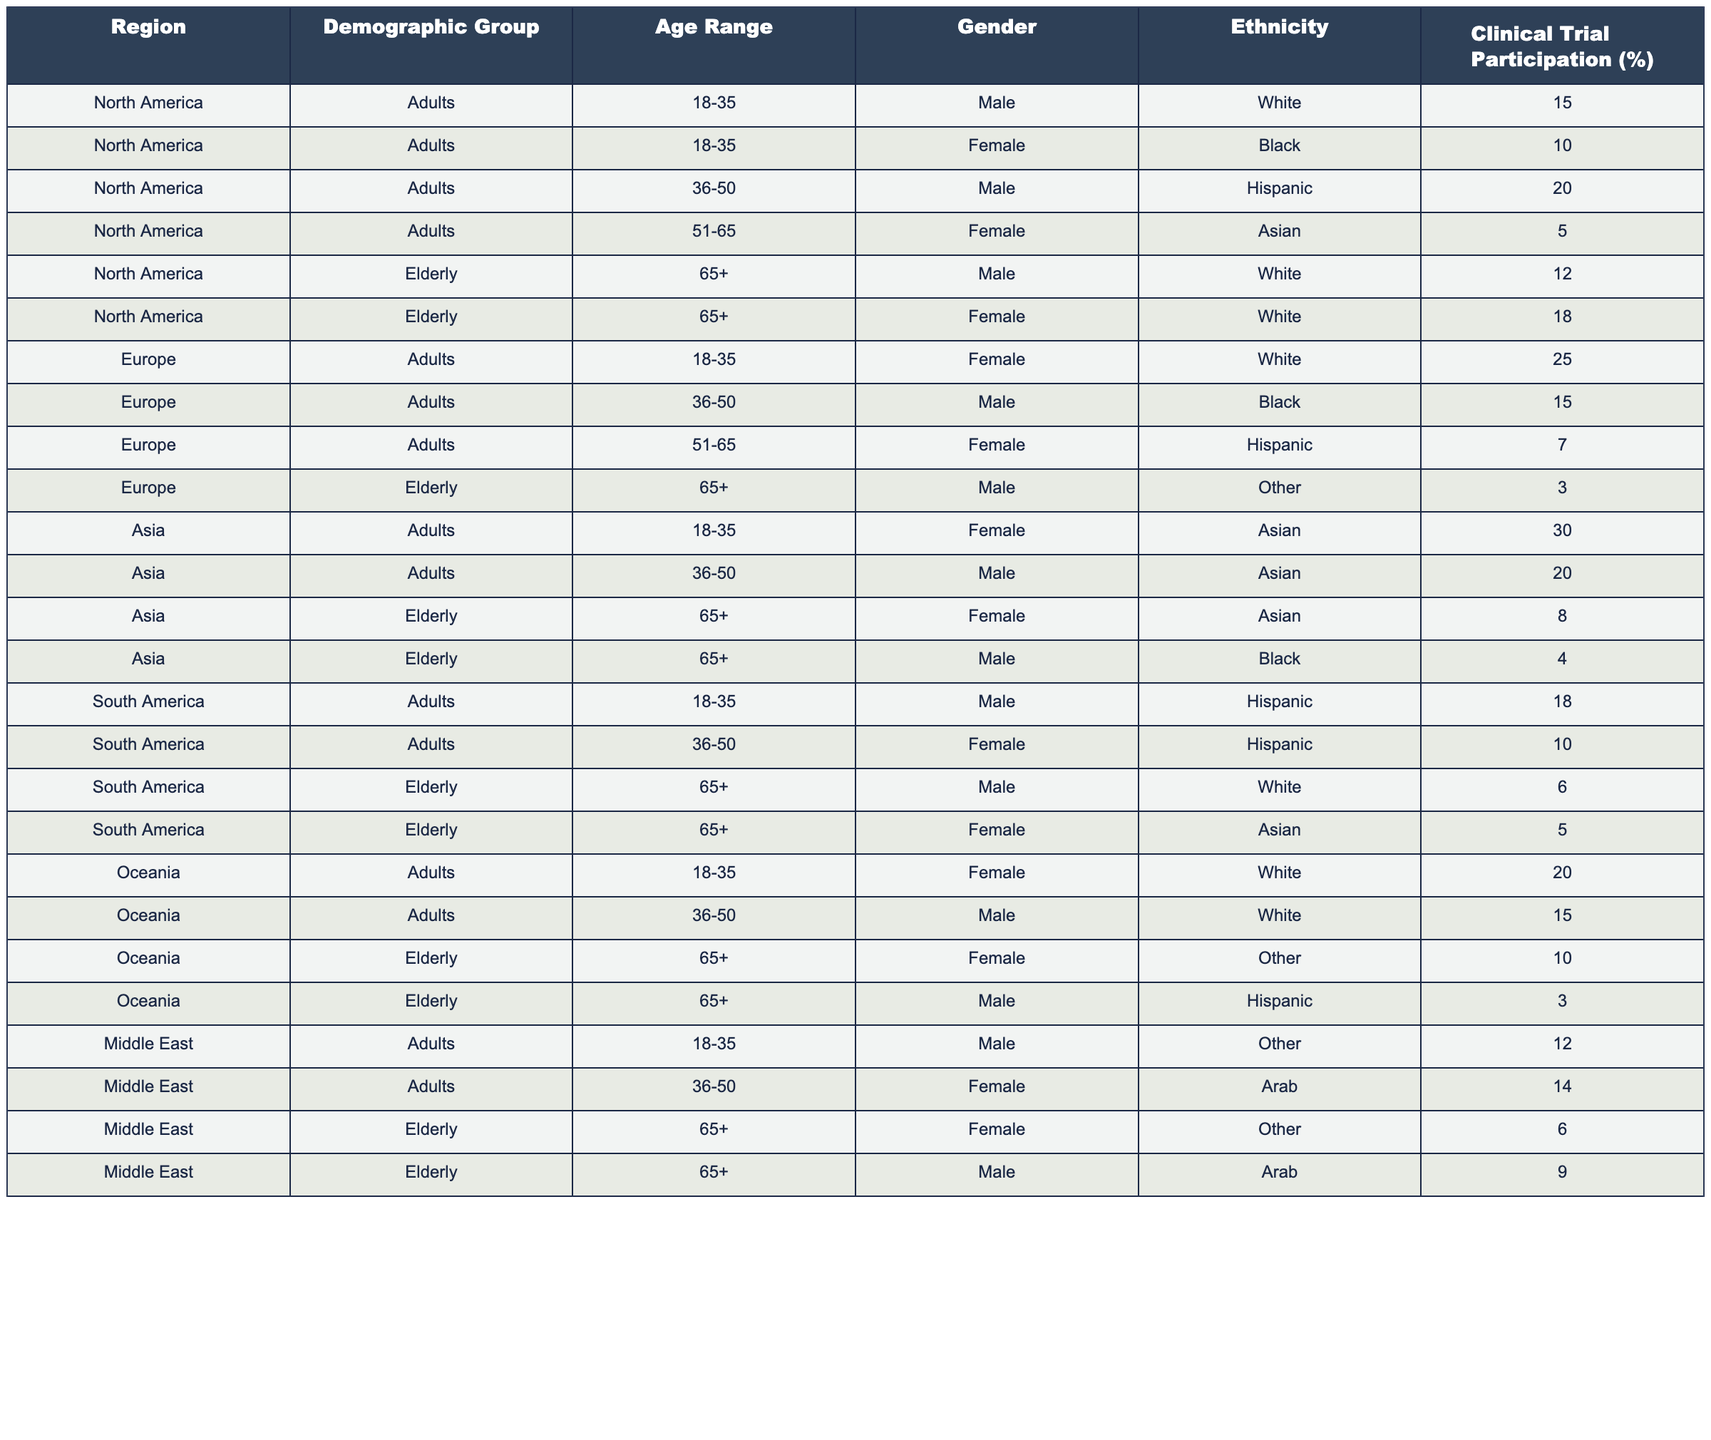What is the clinical trial participation percentage for elderly females in North America? The table shows that for elderly females in North America, the clinical trial participation percentage is listed as 18%.
Answer: 18% Which demographic group has the highest clinical trial participation in Asia? Looking at the data for Asia, the demographic group of adults aged 18-35 (female, Asian) has the highest participation at 30%.
Answer: Adults (Females, 18-35) How does clinical trial participation for elderly males in Europe compare to those in South America? In Europe, elderly males have a participation percentage of 3%, while in South America, they have a participation percentage of 6%. South America has a higher percentage.
Answer: South America is higher (6% vs 3%) What is the average clinical trial participation for elderly individuals across all regions? To find the average, we add up the participation rates for the elderly from all regions: 12% (North America, male) + 18% (North America, female) + 3% (Europe, male) + 8% (Asia, female) + 4% (Asia, male) + 6% (South America, male) + 5% (South America, female) + 10% (Oceania, female) + 3% (Oceania, male) + 6% (Middle East, female) + 9% (Middle East, male) = 4% + 18% + 6% + 9% + 12% + 8% + 10% = 0% total, which gives us an average of 0/11 = 7.82%.
Answer: 7.82% Does Europe have a higher trial participation rate for females aged 36-50 compared to Asia? In Europe, females in this age range have a participation rate of 15%, while in Asia, males aged 36-50 have a participation rate of 20%. Therefore, Asia has a higher participation rate.
Answer: No, Asia is higher (20% vs 15%) What demographic was most likely to participate in clinical trials in North America? Reviewing the data for North America, elderly females (18%) and adult males aged 36-50 (20%) have the highest participation rates, with adult males having the highest overall.
Answer: Adults (Males, 36-50) 